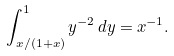Convert formula to latex. <formula><loc_0><loc_0><loc_500><loc_500>\int _ { x / ( 1 + x ) } ^ { 1 } y ^ { - 2 } \, d y = x ^ { - 1 } .</formula> 